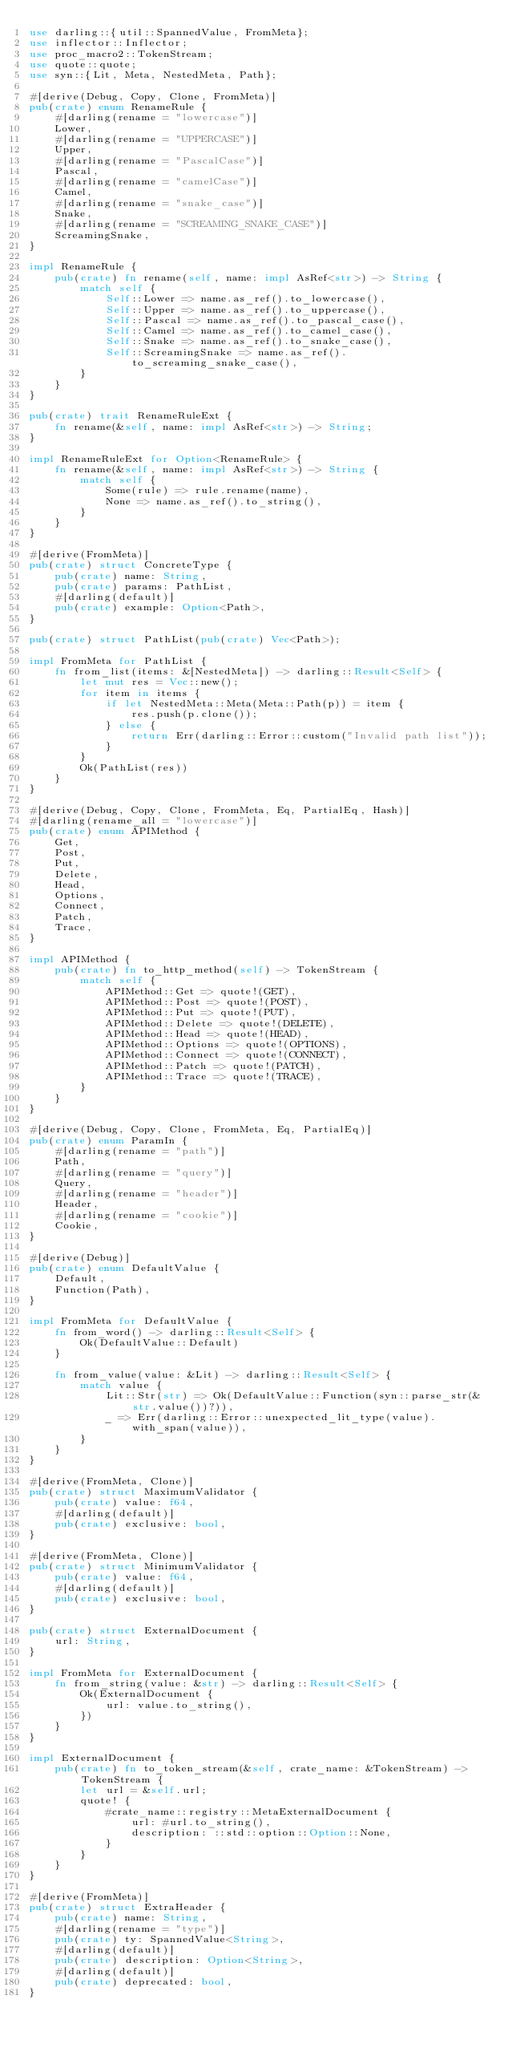<code> <loc_0><loc_0><loc_500><loc_500><_Rust_>use darling::{util::SpannedValue, FromMeta};
use inflector::Inflector;
use proc_macro2::TokenStream;
use quote::quote;
use syn::{Lit, Meta, NestedMeta, Path};

#[derive(Debug, Copy, Clone, FromMeta)]
pub(crate) enum RenameRule {
    #[darling(rename = "lowercase")]
    Lower,
    #[darling(rename = "UPPERCASE")]
    Upper,
    #[darling(rename = "PascalCase")]
    Pascal,
    #[darling(rename = "camelCase")]
    Camel,
    #[darling(rename = "snake_case")]
    Snake,
    #[darling(rename = "SCREAMING_SNAKE_CASE")]
    ScreamingSnake,
}

impl RenameRule {
    pub(crate) fn rename(self, name: impl AsRef<str>) -> String {
        match self {
            Self::Lower => name.as_ref().to_lowercase(),
            Self::Upper => name.as_ref().to_uppercase(),
            Self::Pascal => name.as_ref().to_pascal_case(),
            Self::Camel => name.as_ref().to_camel_case(),
            Self::Snake => name.as_ref().to_snake_case(),
            Self::ScreamingSnake => name.as_ref().to_screaming_snake_case(),
        }
    }
}

pub(crate) trait RenameRuleExt {
    fn rename(&self, name: impl AsRef<str>) -> String;
}

impl RenameRuleExt for Option<RenameRule> {
    fn rename(&self, name: impl AsRef<str>) -> String {
        match self {
            Some(rule) => rule.rename(name),
            None => name.as_ref().to_string(),
        }
    }
}

#[derive(FromMeta)]
pub(crate) struct ConcreteType {
    pub(crate) name: String,
    pub(crate) params: PathList,
    #[darling(default)]
    pub(crate) example: Option<Path>,
}

pub(crate) struct PathList(pub(crate) Vec<Path>);

impl FromMeta for PathList {
    fn from_list(items: &[NestedMeta]) -> darling::Result<Self> {
        let mut res = Vec::new();
        for item in items {
            if let NestedMeta::Meta(Meta::Path(p)) = item {
                res.push(p.clone());
            } else {
                return Err(darling::Error::custom("Invalid path list"));
            }
        }
        Ok(PathList(res))
    }
}

#[derive(Debug, Copy, Clone, FromMeta, Eq, PartialEq, Hash)]
#[darling(rename_all = "lowercase")]
pub(crate) enum APIMethod {
    Get,
    Post,
    Put,
    Delete,
    Head,
    Options,
    Connect,
    Patch,
    Trace,
}

impl APIMethod {
    pub(crate) fn to_http_method(self) -> TokenStream {
        match self {
            APIMethod::Get => quote!(GET),
            APIMethod::Post => quote!(POST),
            APIMethod::Put => quote!(PUT),
            APIMethod::Delete => quote!(DELETE),
            APIMethod::Head => quote!(HEAD),
            APIMethod::Options => quote!(OPTIONS),
            APIMethod::Connect => quote!(CONNECT),
            APIMethod::Patch => quote!(PATCH),
            APIMethod::Trace => quote!(TRACE),
        }
    }
}

#[derive(Debug, Copy, Clone, FromMeta, Eq, PartialEq)]
pub(crate) enum ParamIn {
    #[darling(rename = "path")]
    Path,
    #[darling(rename = "query")]
    Query,
    #[darling(rename = "header")]
    Header,
    #[darling(rename = "cookie")]
    Cookie,
}

#[derive(Debug)]
pub(crate) enum DefaultValue {
    Default,
    Function(Path),
}

impl FromMeta for DefaultValue {
    fn from_word() -> darling::Result<Self> {
        Ok(DefaultValue::Default)
    }

    fn from_value(value: &Lit) -> darling::Result<Self> {
        match value {
            Lit::Str(str) => Ok(DefaultValue::Function(syn::parse_str(&str.value())?)),
            _ => Err(darling::Error::unexpected_lit_type(value).with_span(value)),
        }
    }
}

#[derive(FromMeta, Clone)]
pub(crate) struct MaximumValidator {
    pub(crate) value: f64,
    #[darling(default)]
    pub(crate) exclusive: bool,
}

#[derive(FromMeta, Clone)]
pub(crate) struct MinimumValidator {
    pub(crate) value: f64,
    #[darling(default)]
    pub(crate) exclusive: bool,
}

pub(crate) struct ExternalDocument {
    url: String,
}

impl FromMeta for ExternalDocument {
    fn from_string(value: &str) -> darling::Result<Self> {
        Ok(ExternalDocument {
            url: value.to_string(),
        })
    }
}

impl ExternalDocument {
    pub(crate) fn to_token_stream(&self, crate_name: &TokenStream) -> TokenStream {
        let url = &self.url;
        quote! {
            #crate_name::registry::MetaExternalDocument {
                url: #url.to_string(),
                description: ::std::option::Option::None,
            }
        }
    }
}

#[derive(FromMeta)]
pub(crate) struct ExtraHeader {
    pub(crate) name: String,
    #[darling(rename = "type")]
    pub(crate) ty: SpannedValue<String>,
    #[darling(default)]
    pub(crate) description: Option<String>,
    #[darling(default)]
    pub(crate) deprecated: bool,
}
</code> 